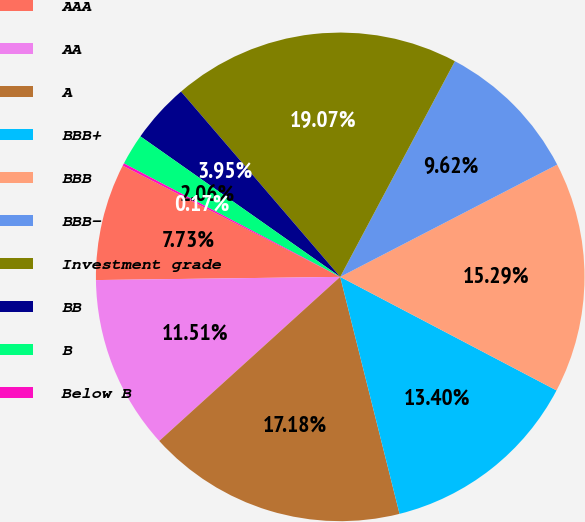Convert chart. <chart><loc_0><loc_0><loc_500><loc_500><pie_chart><fcel>AAA<fcel>AA<fcel>A<fcel>BBB+<fcel>BBB<fcel>BBB-<fcel>Investment grade<fcel>BB<fcel>B<fcel>Below B<nl><fcel>7.73%<fcel>11.51%<fcel>17.18%<fcel>13.4%<fcel>15.29%<fcel>9.62%<fcel>19.07%<fcel>3.95%<fcel>2.06%<fcel>0.17%<nl></chart> 